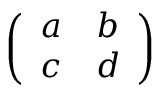Convert formula to latex. <formula><loc_0><loc_0><loc_500><loc_500>\left ( \begin{array} { l l } { a } & { b } \\ { c } & { d } \end{array} \right )</formula> 